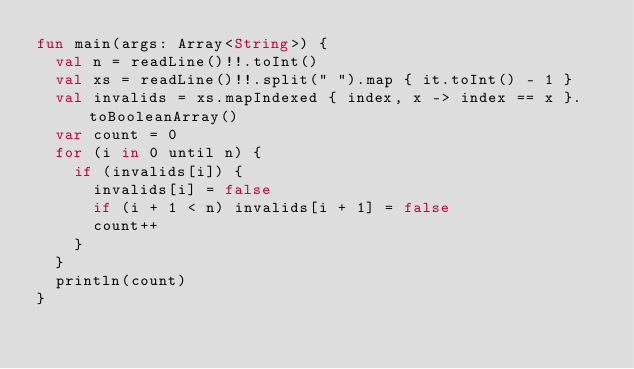<code> <loc_0><loc_0><loc_500><loc_500><_Kotlin_>fun main(args: Array<String>) {
  val n = readLine()!!.toInt()
  val xs = readLine()!!.split(" ").map { it.toInt() - 1 }
  val invalids = xs.mapIndexed { index, x -> index == x }.toBooleanArray()
  var count = 0
  for (i in 0 until n) {
    if (invalids[i]) {
      invalids[i] = false
      if (i + 1 < n) invalids[i + 1] = false
      count++
    }
  }
  println(count)
}
</code> 